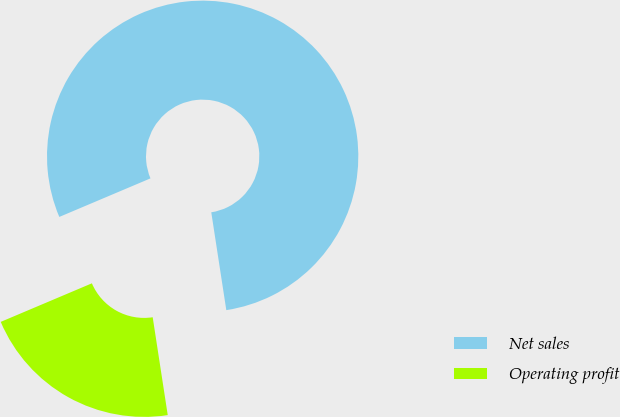<chart> <loc_0><loc_0><loc_500><loc_500><pie_chart><fcel>Net sales<fcel>Operating profit<nl><fcel>78.94%<fcel>21.06%<nl></chart> 